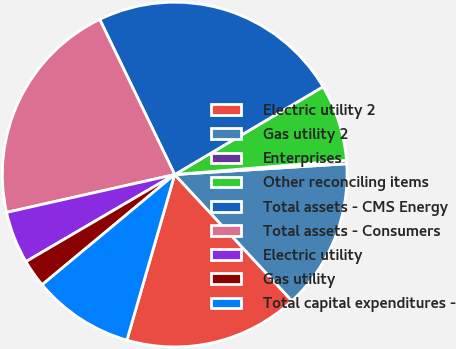Convert chart to OTSL. <chart><loc_0><loc_0><loc_500><loc_500><pie_chart><fcel>Electric utility 2<fcel>Gas utility 2<fcel>Enterprises<fcel>Other reconciling items<fcel>Total assets - CMS Energy<fcel>Total assets - Consumers<fcel>Electric utility<fcel>Gas utility<fcel>Total capital expenditures -<nl><fcel>16.38%<fcel>14.09%<fcel>0.31%<fcel>7.2%<fcel>23.66%<fcel>21.36%<fcel>4.9%<fcel>2.61%<fcel>9.49%<nl></chart> 